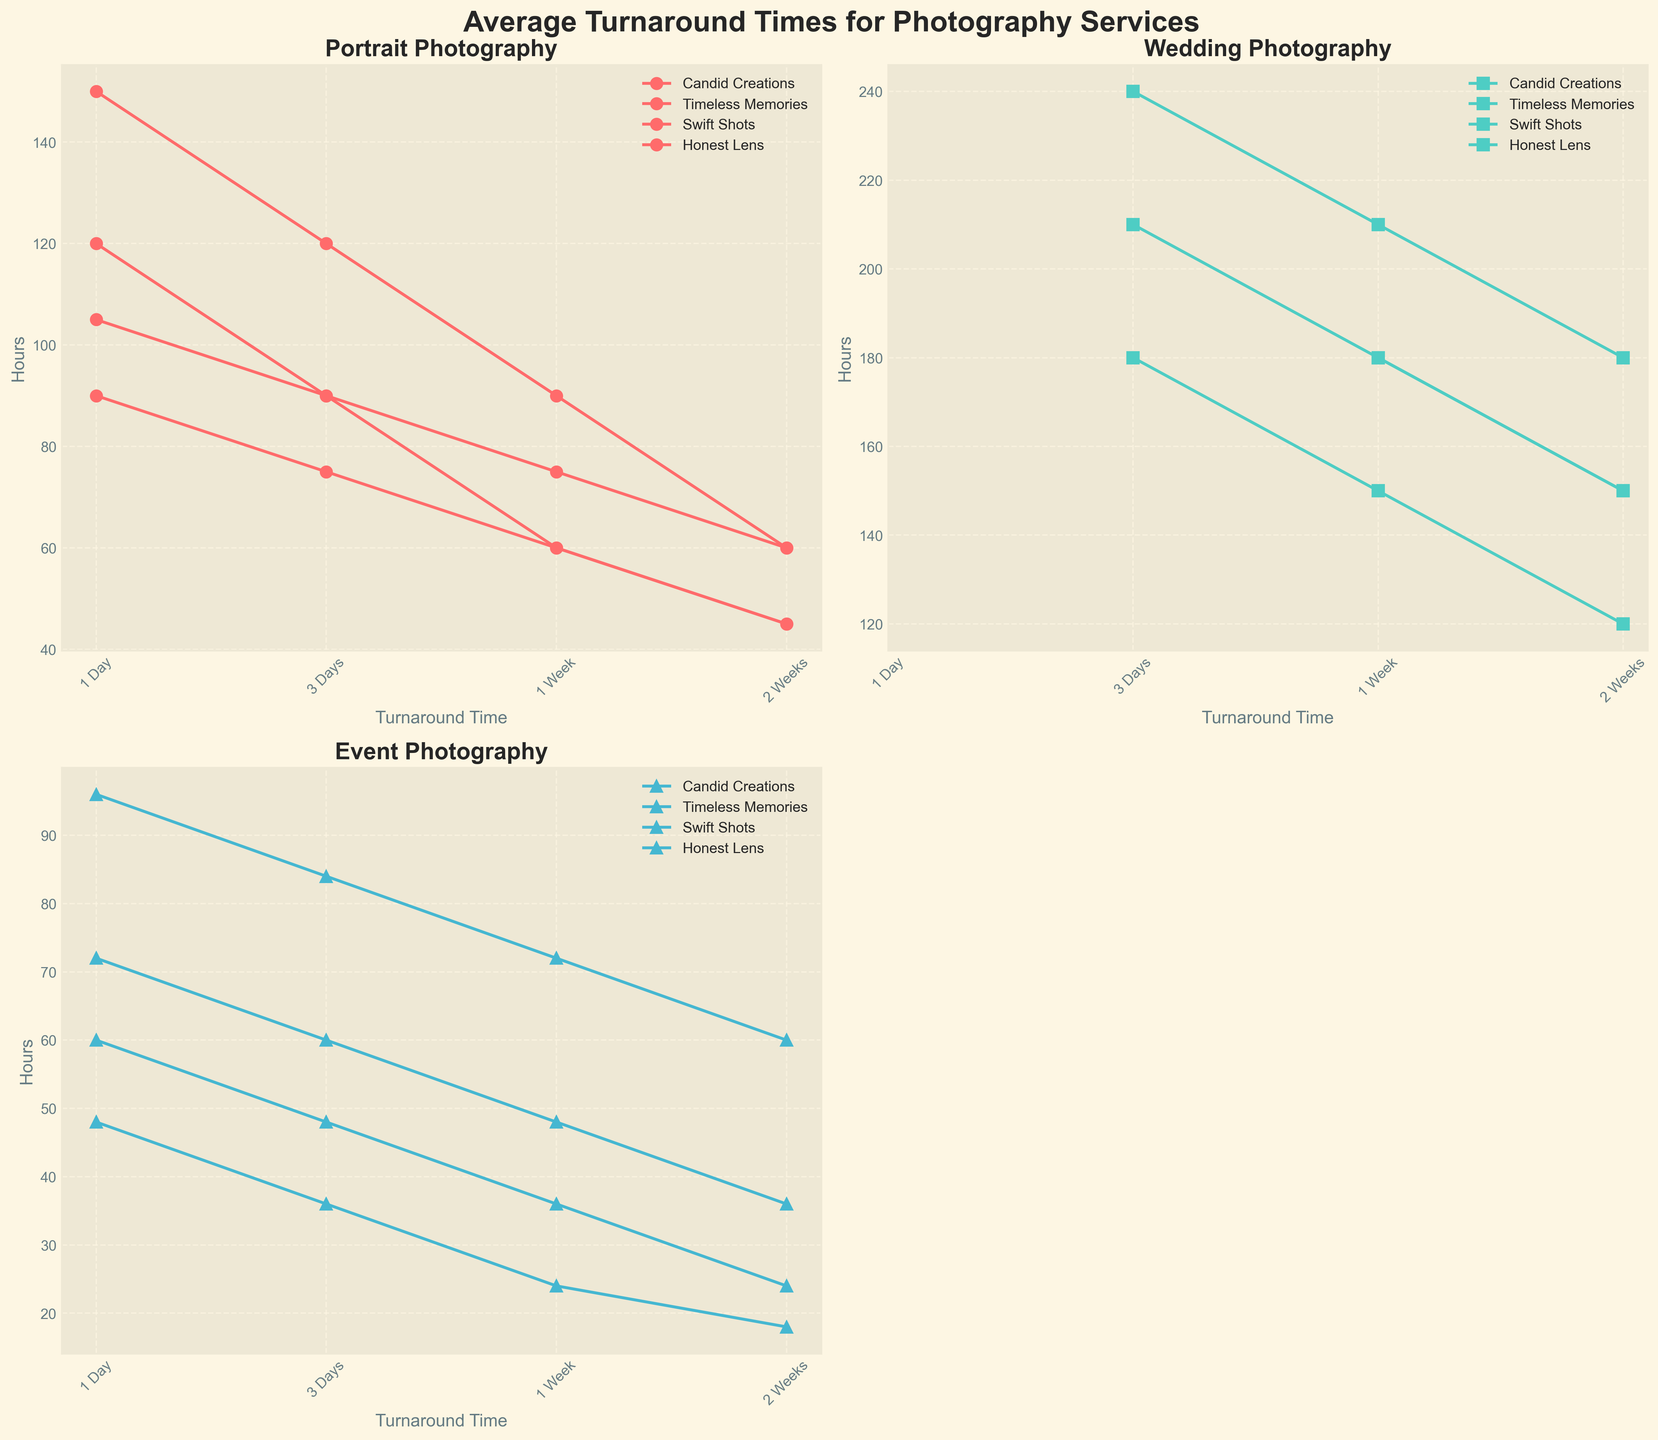What is the title of the figure? The title is the large, bold text at the top of the figure that gives an overview of what the figure is about.
Answer: Average Turnaround Times for Photography Services How many distinct photography services are shown in the figure? The figure consists of multiple panels (subplots), with each panel dedicated to a specific photography service. By counting the number of unique titles within the subplots, we can determine the number of services represented.
Answer: 3 Which studio has the longest turnaround time for 1-week Wedding photography? First, locate the Wedding subplot. Next, identify the lines corresponding to each studio and look at their 1-week turnaround times. Compare these times to determine the longest one.
Answer: Timeless Memories What is the difference in turnaround time between '1 Day' and '2 Weeks' for Candid Creations' Event photography service? In the Event service subplot, find the data points for Candid Creations. Calculate the difference between the '1 Day' turnaround time (72 hours) and the '2 Weeks' turnaround time (36 hours).
Answer: 36 hours Which service has the most rapid reduction in turnaround time after 3 days for Swift Shots? Examine the Swift Shots data across all three services. Identify the steepest drop in the graph from 3 days to 1 week for each service. Compare these drops to find out which service has the most significant reduction.
Answer: Event Among all the studios, which has the shortest turnaround time for Portrait photography in 2 weeks? Focus on the Portrait photography subplot. Identify the data points for each studio at the 2-week mark and compare them to determine the shortest time.
Answer: Swift Shots How does the turnaround time for Event photography at Timeless Memories compare between 1 week and 2 weeks? In the Event photography subplot, find the turnaround times for Timeless Memories at both 1 week (72 hours) and 2 weeks (60 hours). Subtract the 2-week time from the 1-week time to determine the difference.
Answer: 12 hours Do any studios provide 1-day turnaround times for Wedding photography? Look at the Wedding photography subplot and check whether any of the data lines display values at the 1-day mark.
Answer: No Which studio shows the most consistency in turnaround times across all photography services? Compare the general shape and "smoothness" of the graphs for each studio across the three subplots (Portrait, Wedding, Event). The studio with the least variability and most consistent slopes represents the most consistent turnaround times.
Answer: Swift Shots 